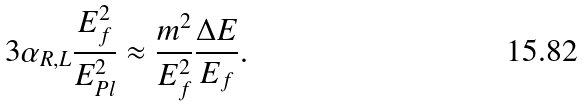<formula> <loc_0><loc_0><loc_500><loc_500>3 \alpha _ { R , L } \frac { E _ { f } ^ { 2 } } { E _ { P l } ^ { 2 } } \approx \frac { m ^ { 2 } } { E _ { f } ^ { 2 } } \frac { \Delta E } { E _ { f } } .</formula> 